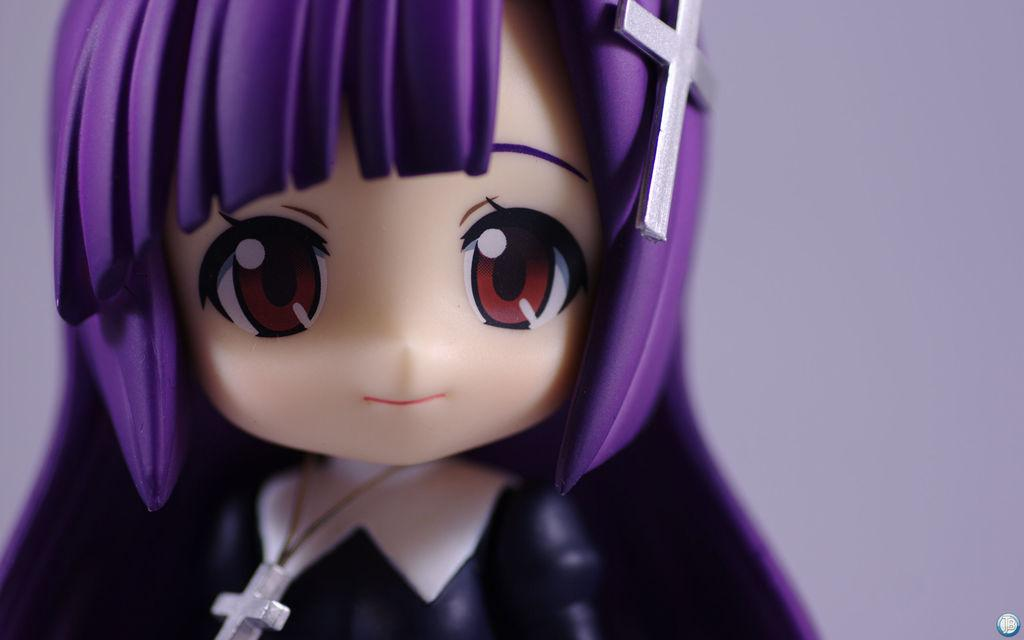What is the main subject in the image? There is a doll in the image. How many snails can be seen crawling on the doll in the image? There are no snails present in the image; it features a doll. What type of car is parked next to the doll in the image? There is no car present in the image; it only features a doll. 